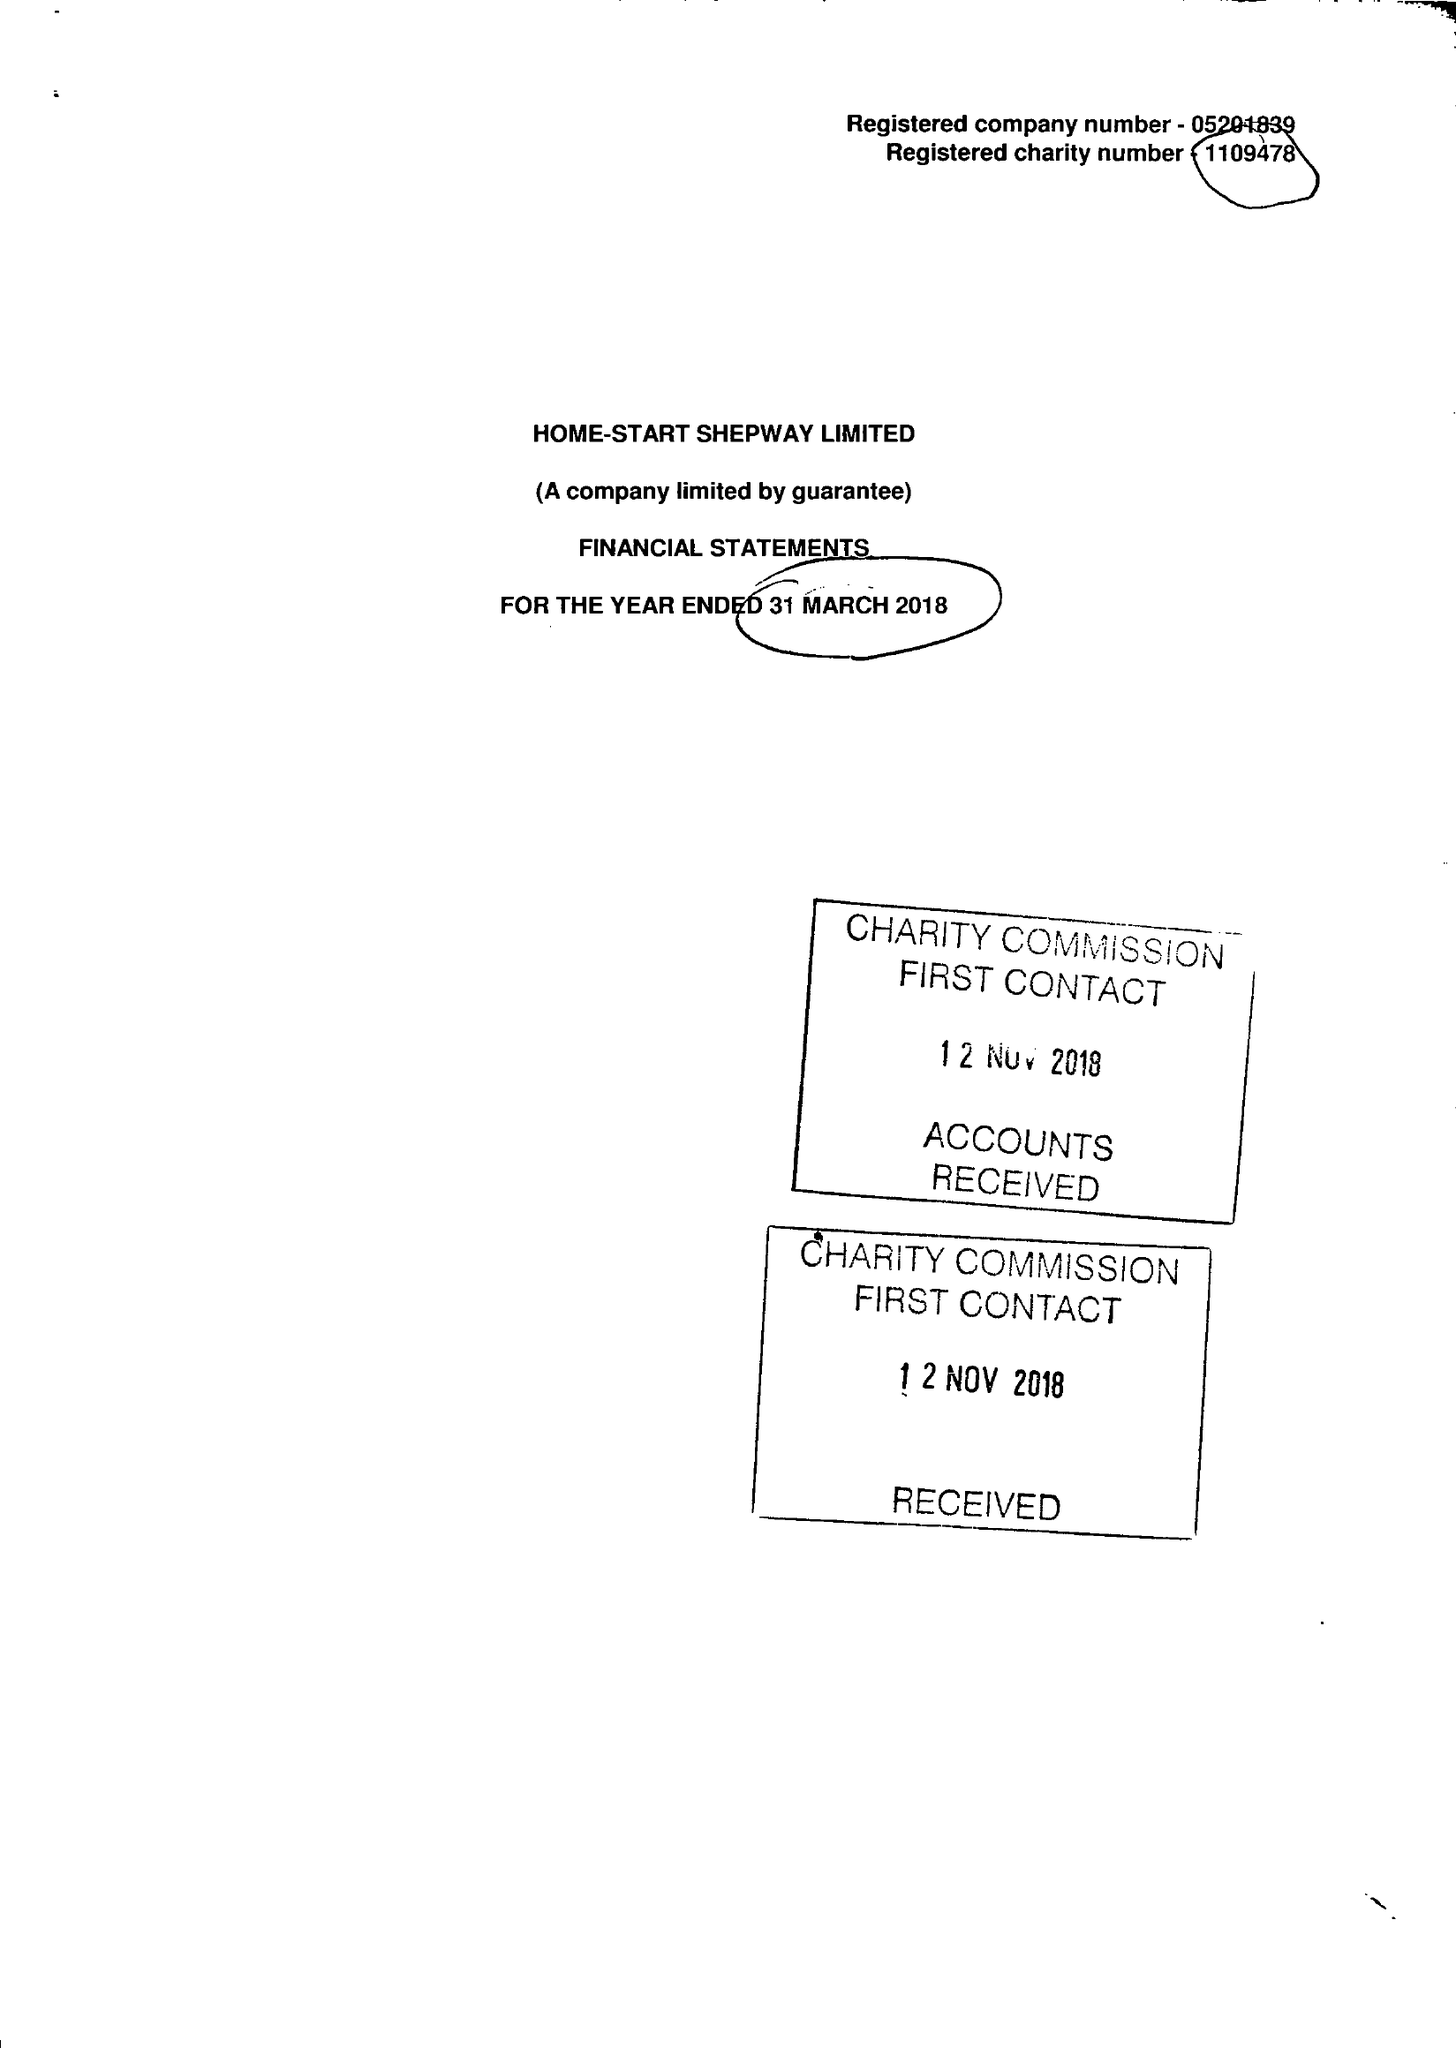What is the value for the income_annually_in_british_pounds?
Answer the question using a single word or phrase. 237236.00 